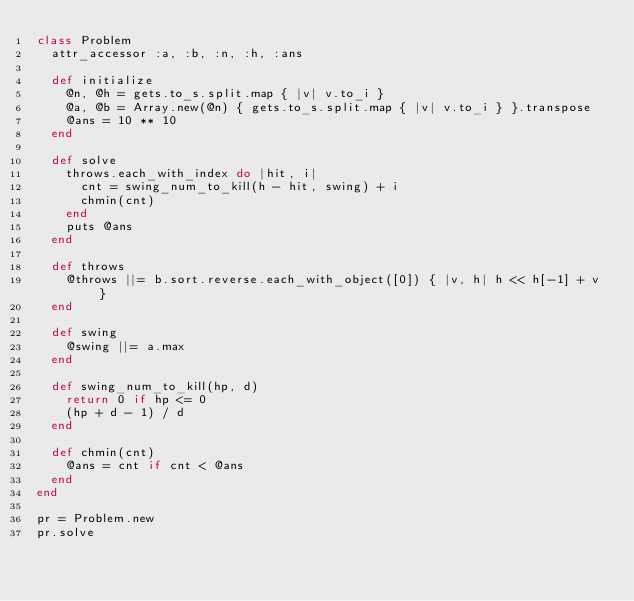Convert code to text. <code><loc_0><loc_0><loc_500><loc_500><_Ruby_>class Problem
  attr_accessor :a, :b, :n, :h, :ans

  def initialize
    @n, @h = gets.to_s.split.map { |v| v.to_i }
    @a, @b = Array.new(@n) { gets.to_s.split.map { |v| v.to_i } }.transpose
    @ans = 10 ** 10
  end

  def solve
    throws.each_with_index do |hit, i|
      cnt = swing_num_to_kill(h - hit, swing) + i
      chmin(cnt)
    end
    puts @ans
  end
  
  def throws
    @throws ||= b.sort.reverse.each_with_object([0]) { |v, h| h << h[-1] + v }
  end

  def swing
    @swing ||= a.max
  end

  def swing_num_to_kill(hp, d)
    return 0 if hp <= 0
    (hp + d - 1) / d
  end

  def chmin(cnt)
    @ans = cnt if cnt < @ans
  end
end

pr = Problem.new
pr.solve
</code> 